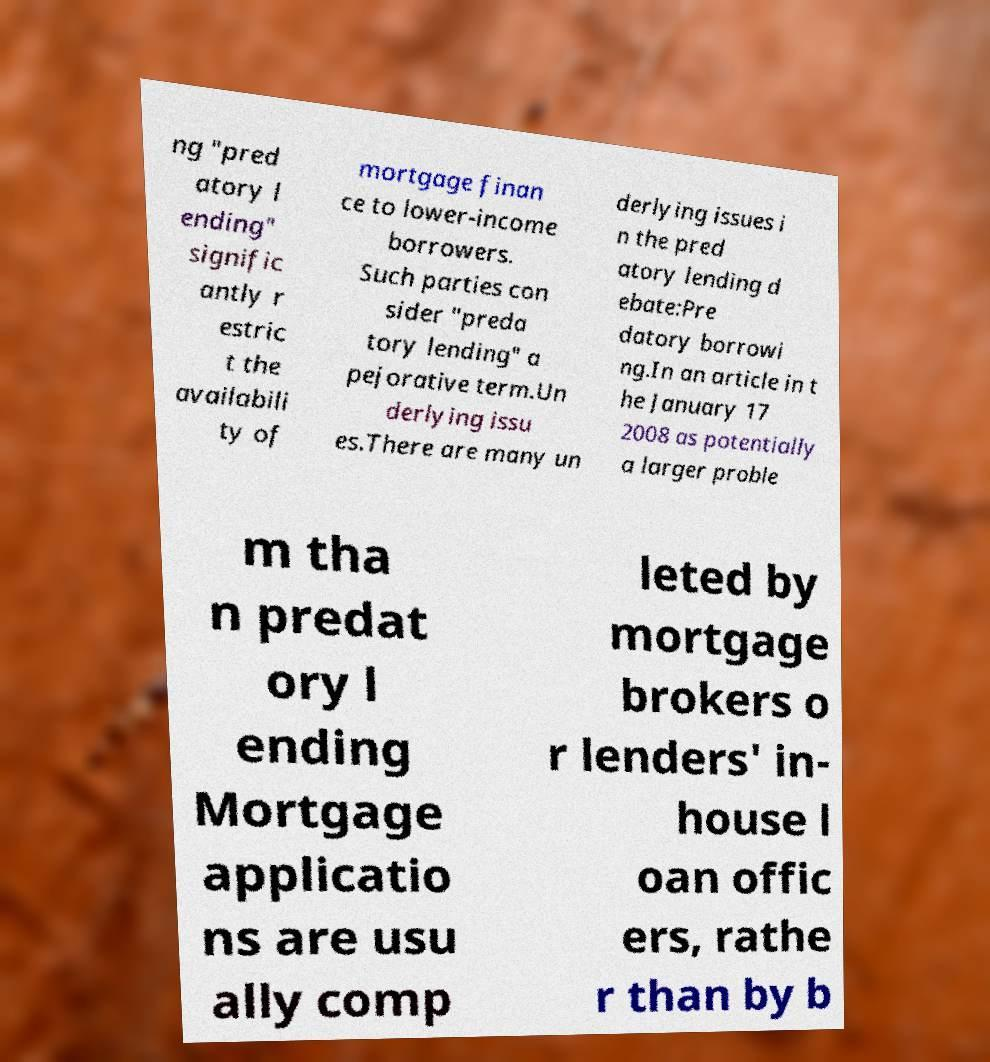What messages or text are displayed in this image? I need them in a readable, typed format. ng "pred atory l ending" signific antly r estric t the availabili ty of mortgage finan ce to lower-income borrowers. Such parties con sider "preda tory lending" a pejorative term.Un derlying issu es.There are many un derlying issues i n the pred atory lending d ebate:Pre datory borrowi ng.In an article in t he January 17 2008 as potentially a larger proble m tha n predat ory l ending Mortgage applicatio ns are usu ally comp leted by mortgage brokers o r lenders' in- house l oan offic ers, rathe r than by b 